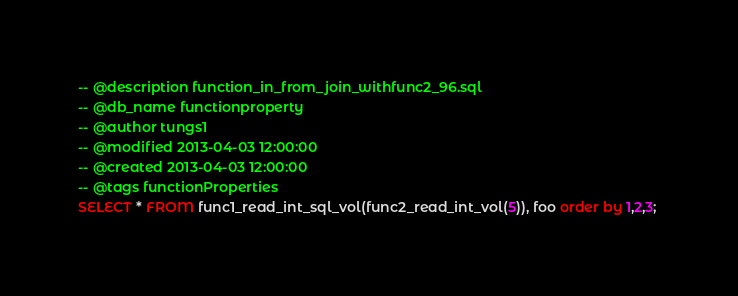<code> <loc_0><loc_0><loc_500><loc_500><_SQL_>-- @description function_in_from_join_withfunc2_96.sql
-- @db_name functionproperty
-- @author tungs1
-- @modified 2013-04-03 12:00:00
-- @created 2013-04-03 12:00:00
-- @tags functionProperties 
SELECT * FROM func1_read_int_sql_vol(func2_read_int_vol(5)), foo order by 1,2,3; 
</code> 